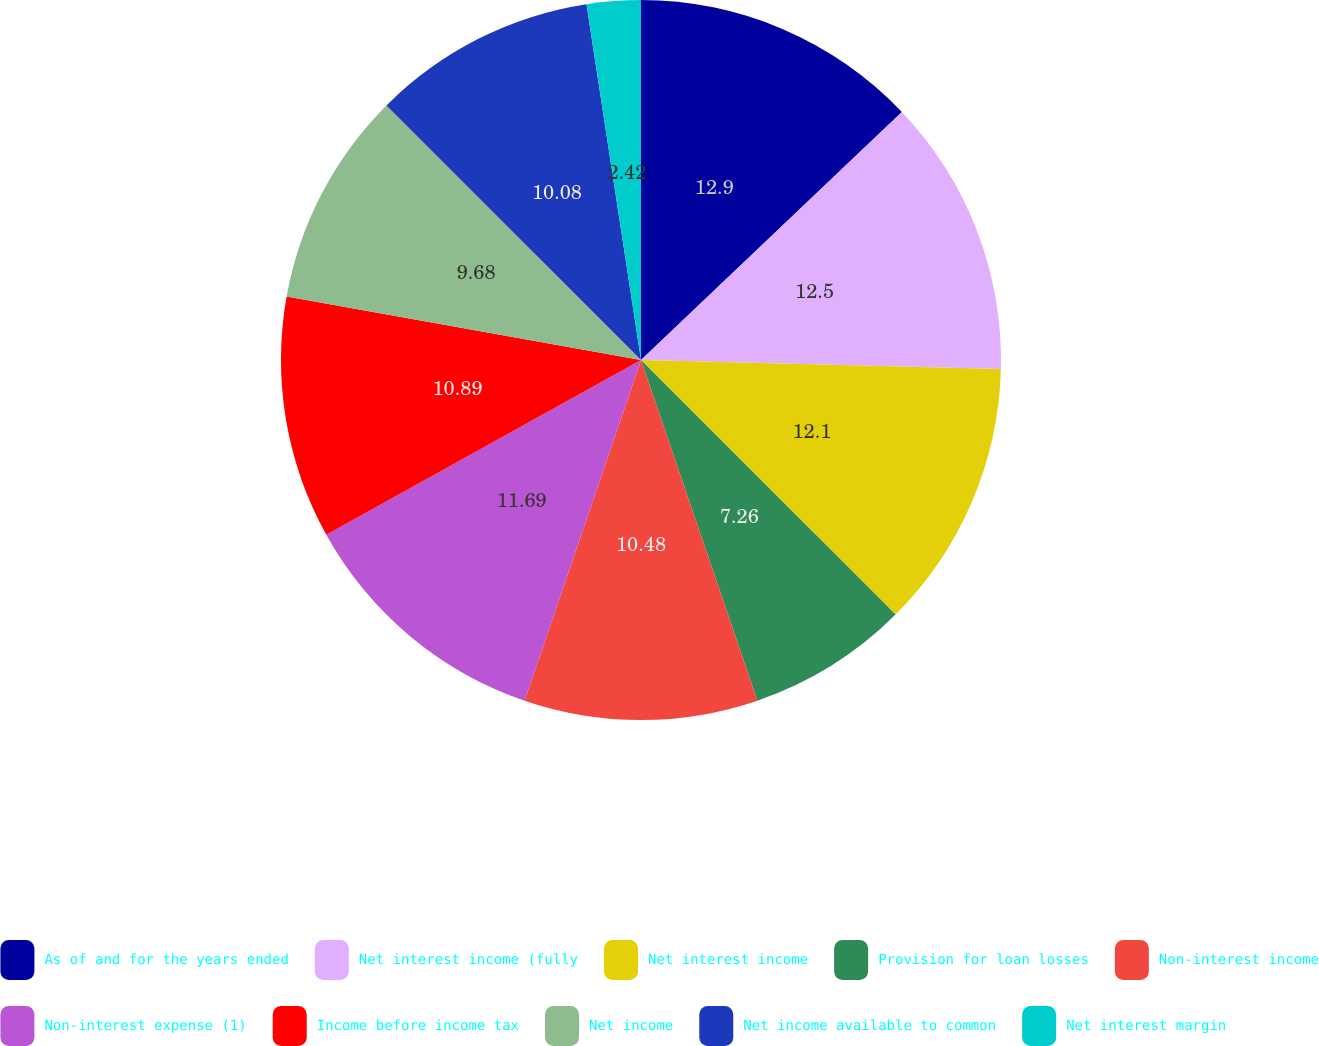Convert chart to OTSL. <chart><loc_0><loc_0><loc_500><loc_500><pie_chart><fcel>As of and for the years ended<fcel>Net interest income (fully<fcel>Net interest income<fcel>Provision for loan losses<fcel>Non-interest income<fcel>Non-interest expense (1)<fcel>Income before income tax<fcel>Net income<fcel>Net income available to common<fcel>Net interest margin<nl><fcel>12.9%<fcel>12.5%<fcel>12.1%<fcel>7.26%<fcel>10.48%<fcel>11.69%<fcel>10.89%<fcel>9.68%<fcel>10.08%<fcel>2.42%<nl></chart> 